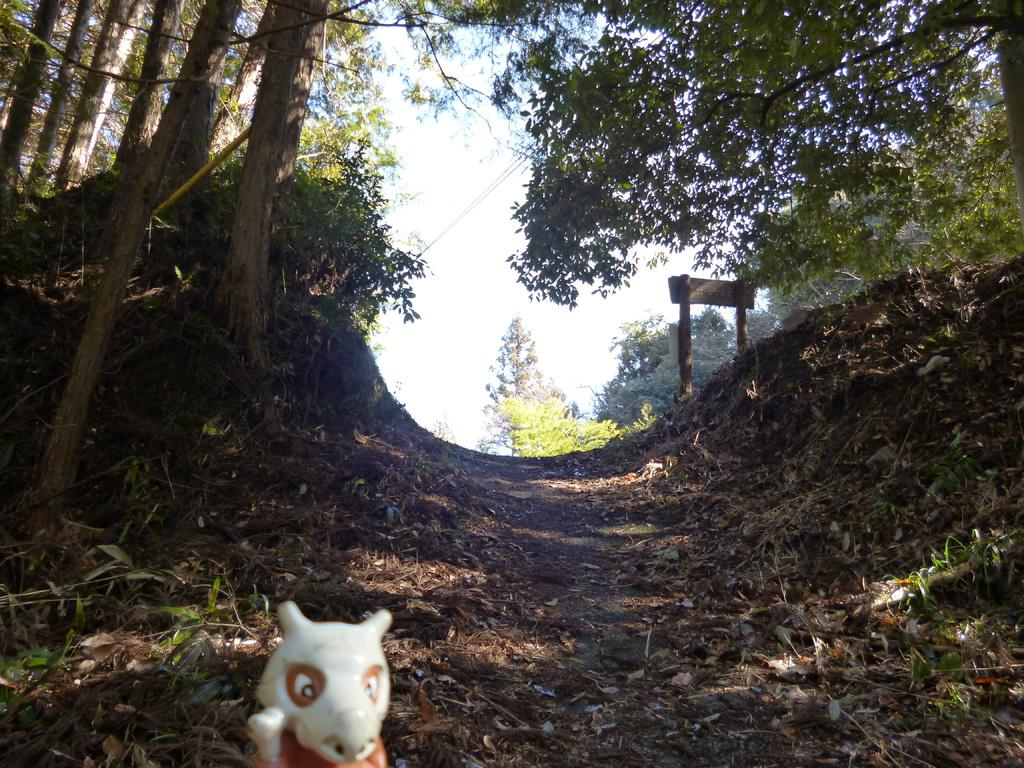What is on the road in the image? There is a toy on the road in the image. What type of natural elements can be seen in the image? There are trees visible in the image. What structure is present in the image? There is a board attached to poles in the image. What type of treatment is the stranger receiving in the image? There is no stranger present in the image, and therefore no treatment can be observed. 